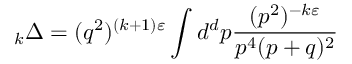Convert formula to latex. <formula><loc_0><loc_0><loc_500><loc_500>_ { k } \Delta = ( q ^ { 2 } ) ^ { ( k + 1 ) \varepsilon } \int d ^ { d } p \frac { ( p ^ { 2 } ) ^ { - k \varepsilon } } { p ^ { 4 } ( p + q ) ^ { 2 } }</formula> 